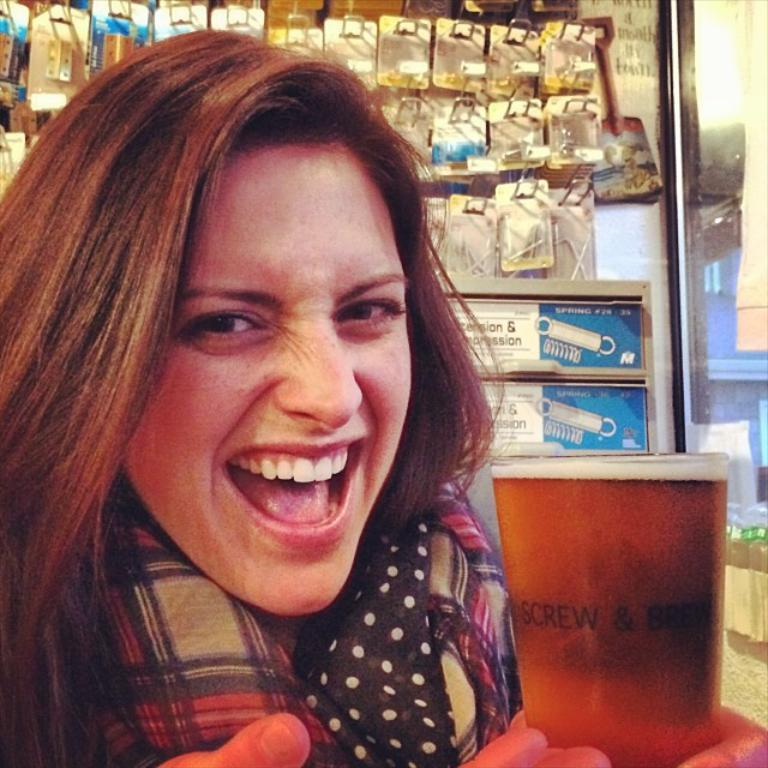What is the woman wearing around her neck in the image? The woman is wearing a scarf in the image. What is the woman's facial expression in the image? The woman is smiling in the image. What can be seen on the wall in the image? There are things on the wall in the image. What is the woman holding in her hand in the image? The woman is holding a glass in the image. How many frogs are sitting on the woman's tail in the image? There are no frogs or tails present in the image. 